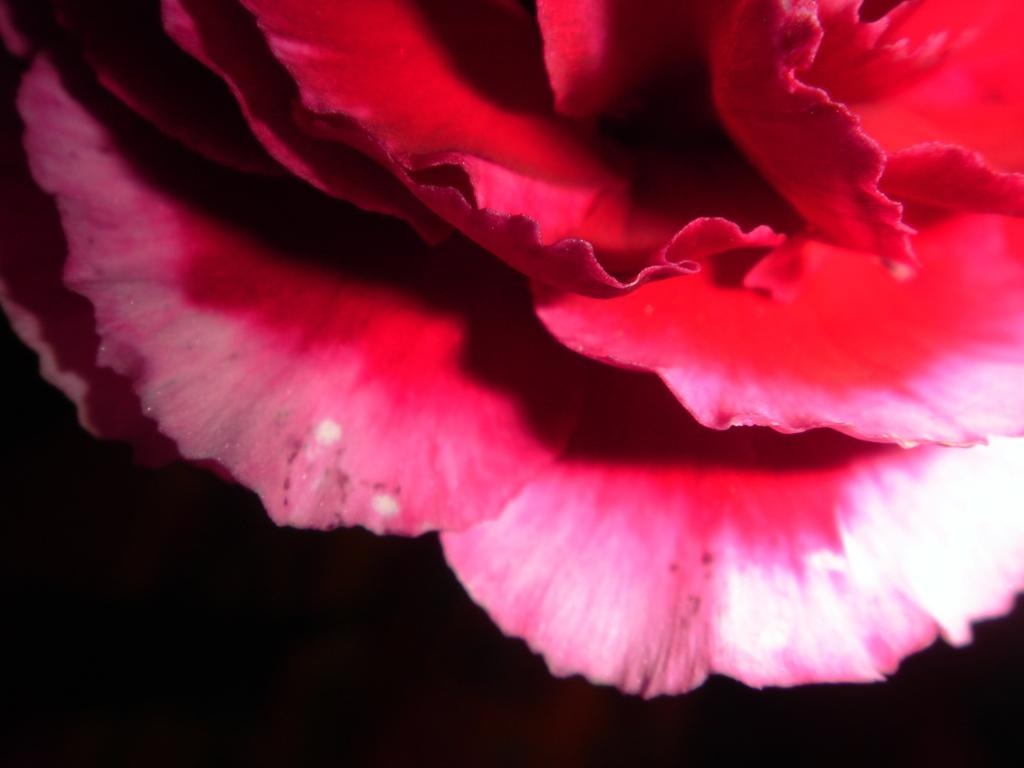What is the main subject of the image? There is a flower in the image. Can you describe the background of the image? The background of the image is dark. What type of jam is being spread on the squirrel in the image? There is no squirrel or jam present in the image; it features a flower with a dark background. 